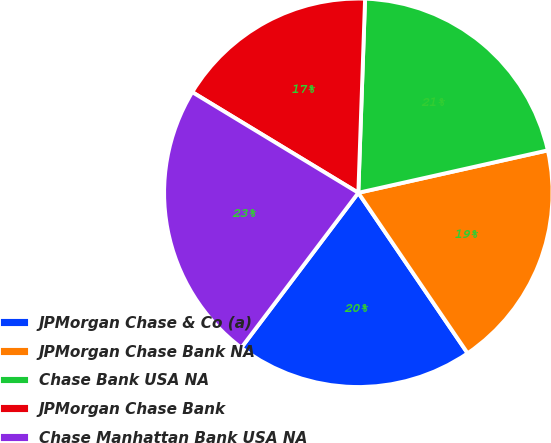Convert chart to OTSL. <chart><loc_0><loc_0><loc_500><loc_500><pie_chart><fcel>JPMorgan Chase & Co (a)<fcel>JPMorgan Chase Bank NA<fcel>Chase Bank USA NA<fcel>JPMorgan Chase Bank<fcel>Chase Manhattan Bank USA NA<nl><fcel>19.81%<fcel>18.99%<fcel>20.94%<fcel>16.88%<fcel>23.38%<nl></chart> 